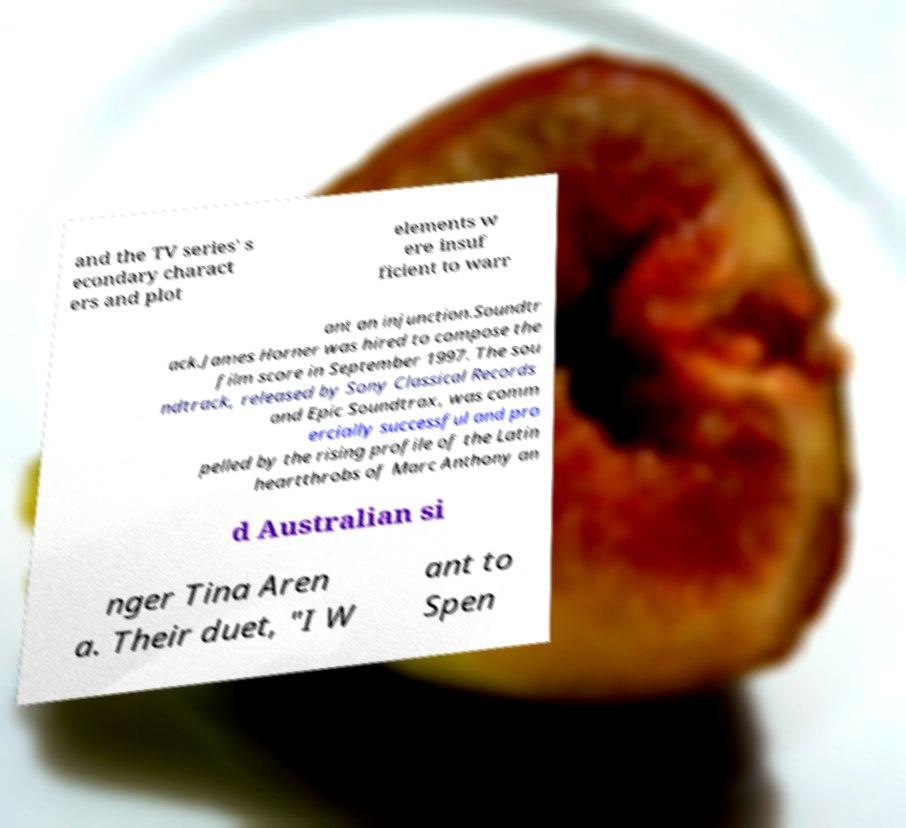Can you read and provide the text displayed in the image?This photo seems to have some interesting text. Can you extract and type it out for me? and the TV series' s econdary charact ers and plot elements w ere insuf ficient to warr ant an injunction.Soundtr ack.James Horner was hired to compose the film score in September 1997. The sou ndtrack, released by Sony Classical Records and Epic Soundtrax, was comm ercially successful and pro pelled by the rising profile of the Latin heartthrobs of Marc Anthony an d Australian si nger Tina Aren a. Their duet, "I W ant to Spen 